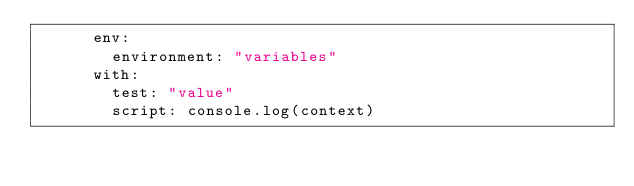Convert code to text. <code><loc_0><loc_0><loc_500><loc_500><_YAML_>      env:
        environment: "variables"
      with:
        test: "value"
        script: console.log(context)
</code> 